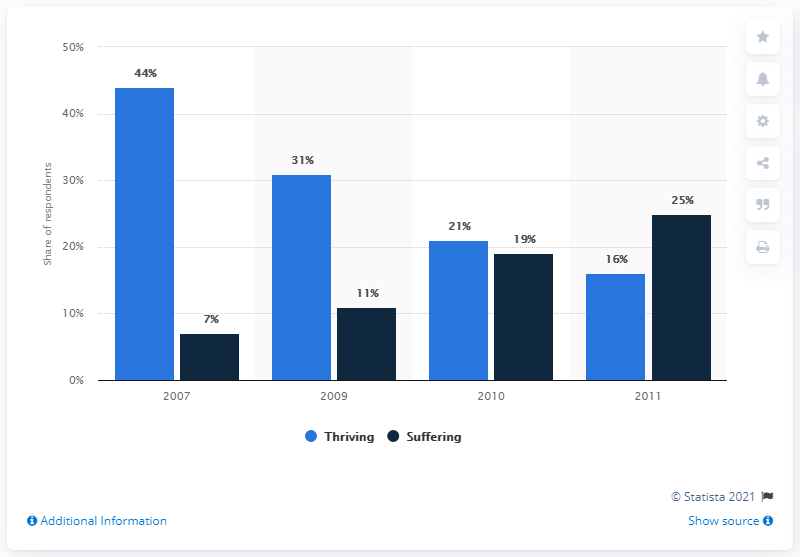Specify some key components in this picture. The instruction is asking to add the values of the leftmost blue bar and the rightmost navy blue bar, which is 69. In 2007, there was a significant contrast in living conditions compared to previous years. 